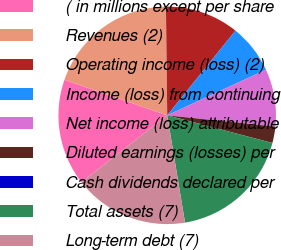Convert chart. <chart><loc_0><loc_0><loc_500><loc_500><pie_chart><fcel>( in millions except per share<fcel>Revenues (2)<fcel>Operating income (loss) (2)<fcel>Income (loss) from continuing<fcel>Net income (loss) attributable<fcel>Diluted earnings (losses) per<fcel>Cash dividends declared per<fcel>Total assets (7)<fcel>Long-term debt (7)<nl><fcel>15.85%<fcel>19.51%<fcel>10.98%<fcel>7.32%<fcel>8.54%<fcel>2.44%<fcel>0.0%<fcel>18.29%<fcel>17.07%<nl></chart> 